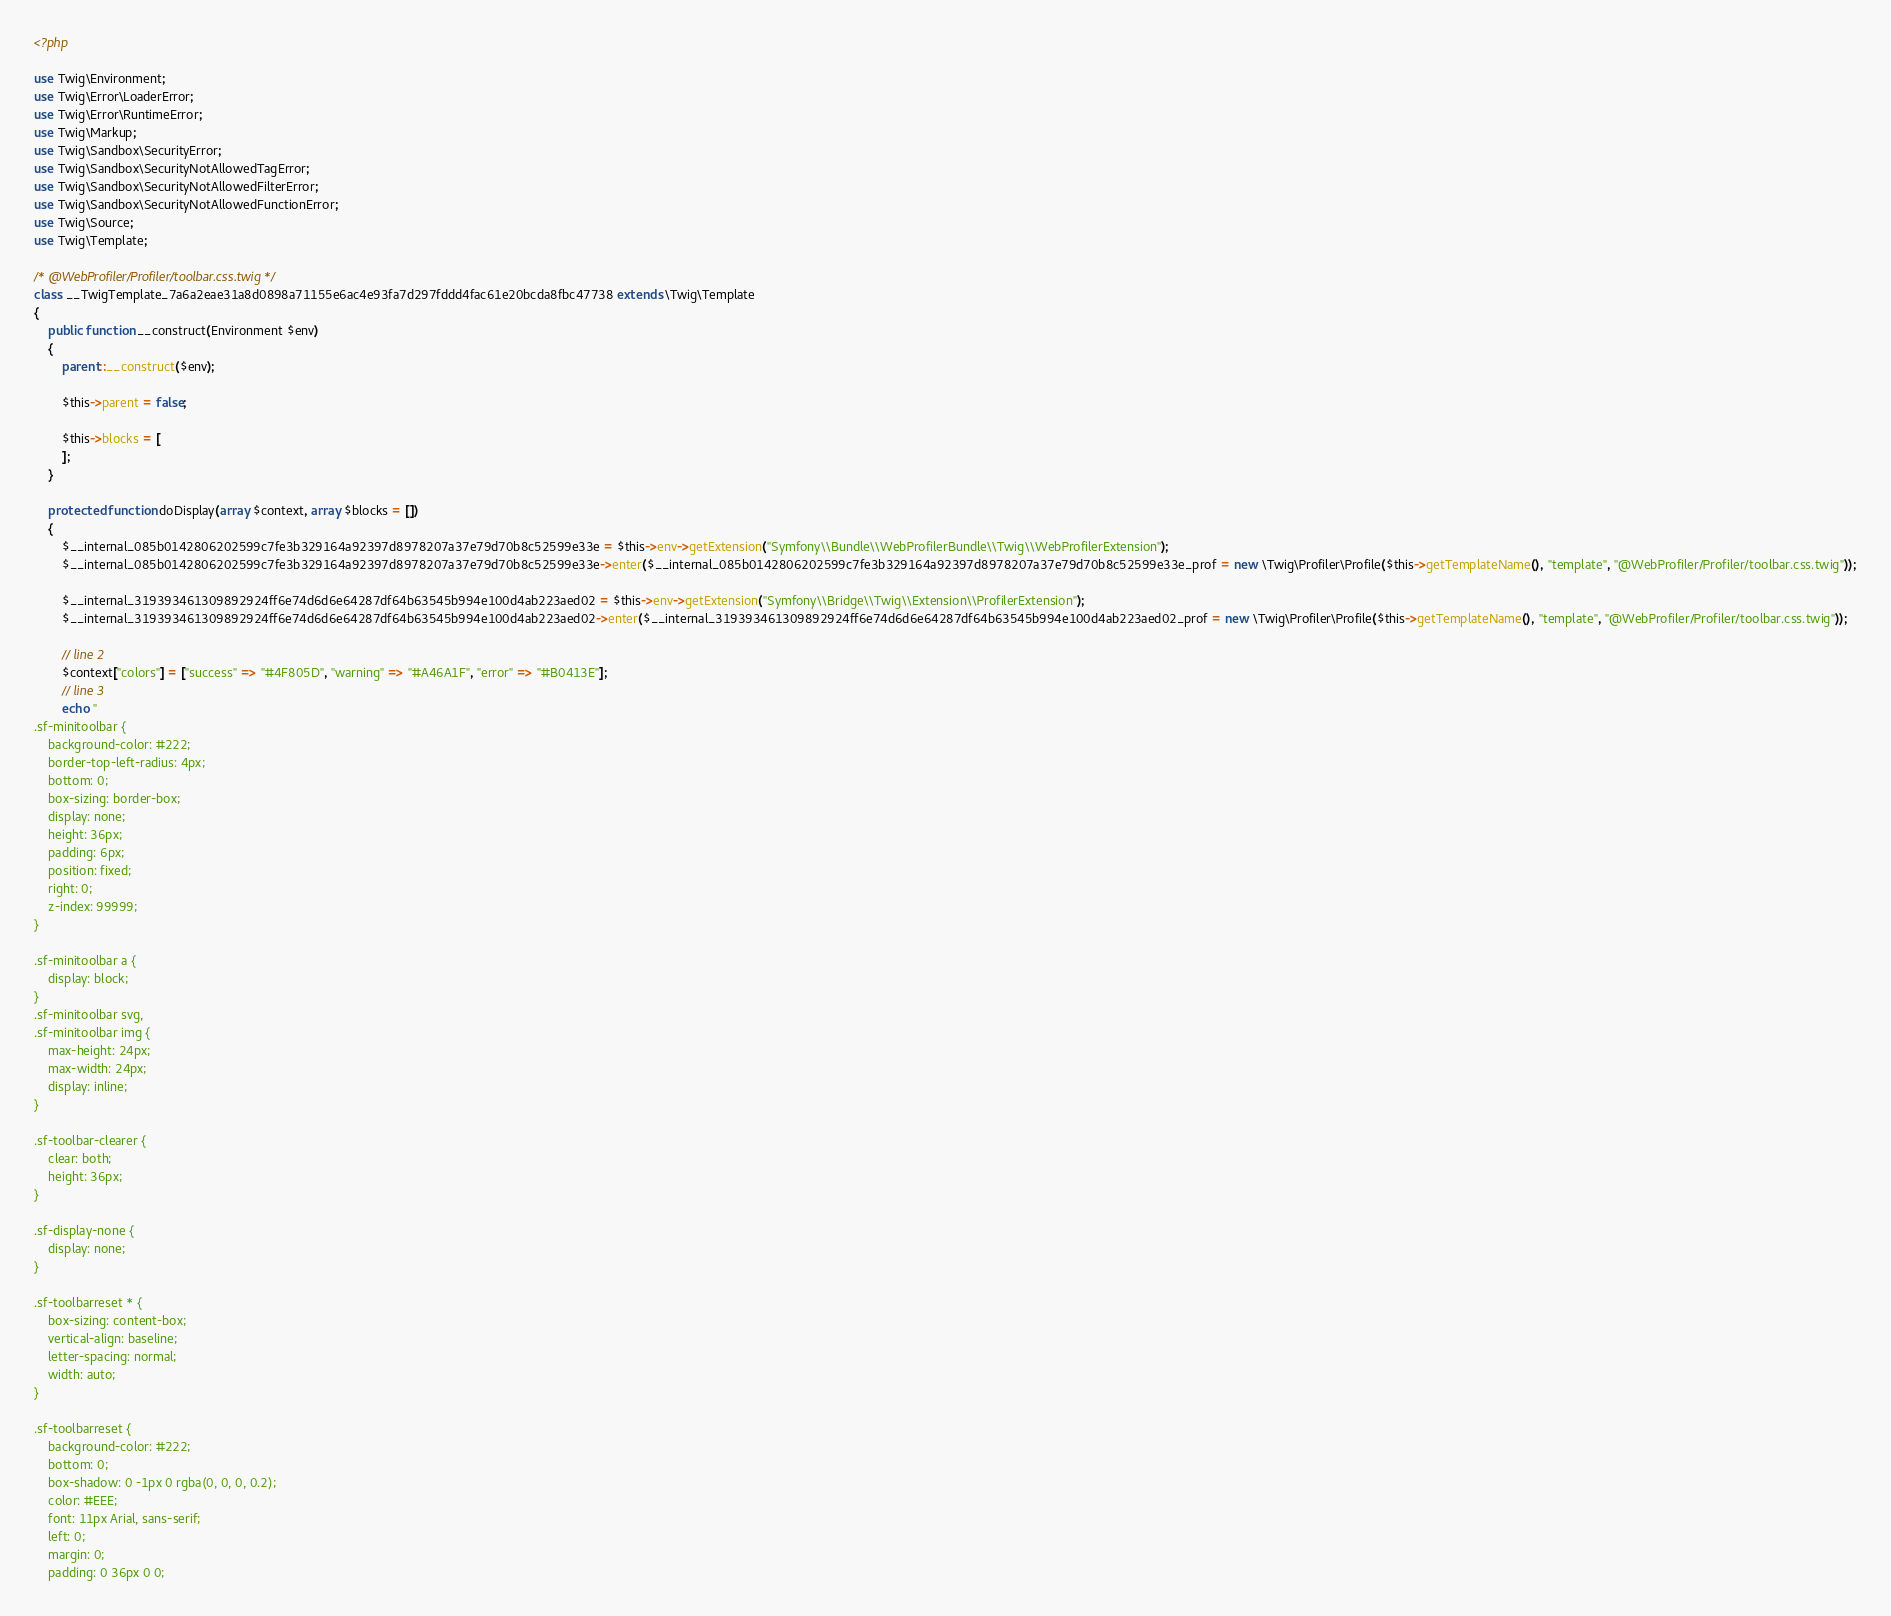<code> <loc_0><loc_0><loc_500><loc_500><_PHP_><?php

use Twig\Environment;
use Twig\Error\LoaderError;
use Twig\Error\RuntimeError;
use Twig\Markup;
use Twig\Sandbox\SecurityError;
use Twig\Sandbox\SecurityNotAllowedTagError;
use Twig\Sandbox\SecurityNotAllowedFilterError;
use Twig\Sandbox\SecurityNotAllowedFunctionError;
use Twig\Source;
use Twig\Template;

/* @WebProfiler/Profiler/toolbar.css.twig */
class __TwigTemplate_7a6a2eae31a8d0898a71155e6ac4e93fa7d297fddd4fac61e20bcda8fbc47738 extends \Twig\Template
{
    public function __construct(Environment $env)
    {
        parent::__construct($env);

        $this->parent = false;

        $this->blocks = [
        ];
    }

    protected function doDisplay(array $context, array $blocks = [])
    {
        $__internal_085b0142806202599c7fe3b329164a92397d8978207a37e79d70b8c52599e33e = $this->env->getExtension("Symfony\\Bundle\\WebProfilerBundle\\Twig\\WebProfilerExtension");
        $__internal_085b0142806202599c7fe3b329164a92397d8978207a37e79d70b8c52599e33e->enter($__internal_085b0142806202599c7fe3b329164a92397d8978207a37e79d70b8c52599e33e_prof = new \Twig\Profiler\Profile($this->getTemplateName(), "template", "@WebProfiler/Profiler/toolbar.css.twig"));

        $__internal_319393461309892924ff6e74d6d6e64287df64b63545b994e100d4ab223aed02 = $this->env->getExtension("Symfony\\Bridge\\Twig\\Extension\\ProfilerExtension");
        $__internal_319393461309892924ff6e74d6d6e64287df64b63545b994e100d4ab223aed02->enter($__internal_319393461309892924ff6e74d6d6e64287df64b63545b994e100d4ab223aed02_prof = new \Twig\Profiler\Profile($this->getTemplateName(), "template", "@WebProfiler/Profiler/toolbar.css.twig"));

        // line 2
        $context["colors"] = ["success" => "#4F805D", "warning" => "#A46A1F", "error" => "#B0413E"];
        // line 3
        echo "
.sf-minitoolbar {
    background-color: #222;
    border-top-left-radius: 4px;
    bottom: 0;
    box-sizing: border-box;
    display: none;
    height: 36px;
    padding: 6px;
    position: fixed;
    right: 0;
    z-index: 99999;
}

.sf-minitoolbar a {
    display: block;
}
.sf-minitoolbar svg,
.sf-minitoolbar img {
    max-height: 24px;
    max-width: 24px;
    display: inline;
}

.sf-toolbar-clearer {
    clear: both;
    height: 36px;
}

.sf-display-none {
    display: none;
}

.sf-toolbarreset * {
    box-sizing: content-box;
    vertical-align: baseline;
    letter-spacing: normal;
    width: auto;
}

.sf-toolbarreset {
    background-color: #222;
    bottom: 0;
    box-shadow: 0 -1px 0 rgba(0, 0, 0, 0.2);
    color: #EEE;
    font: 11px Arial, sans-serif;
    left: 0;
    margin: 0;
    padding: 0 36px 0 0;</code> 